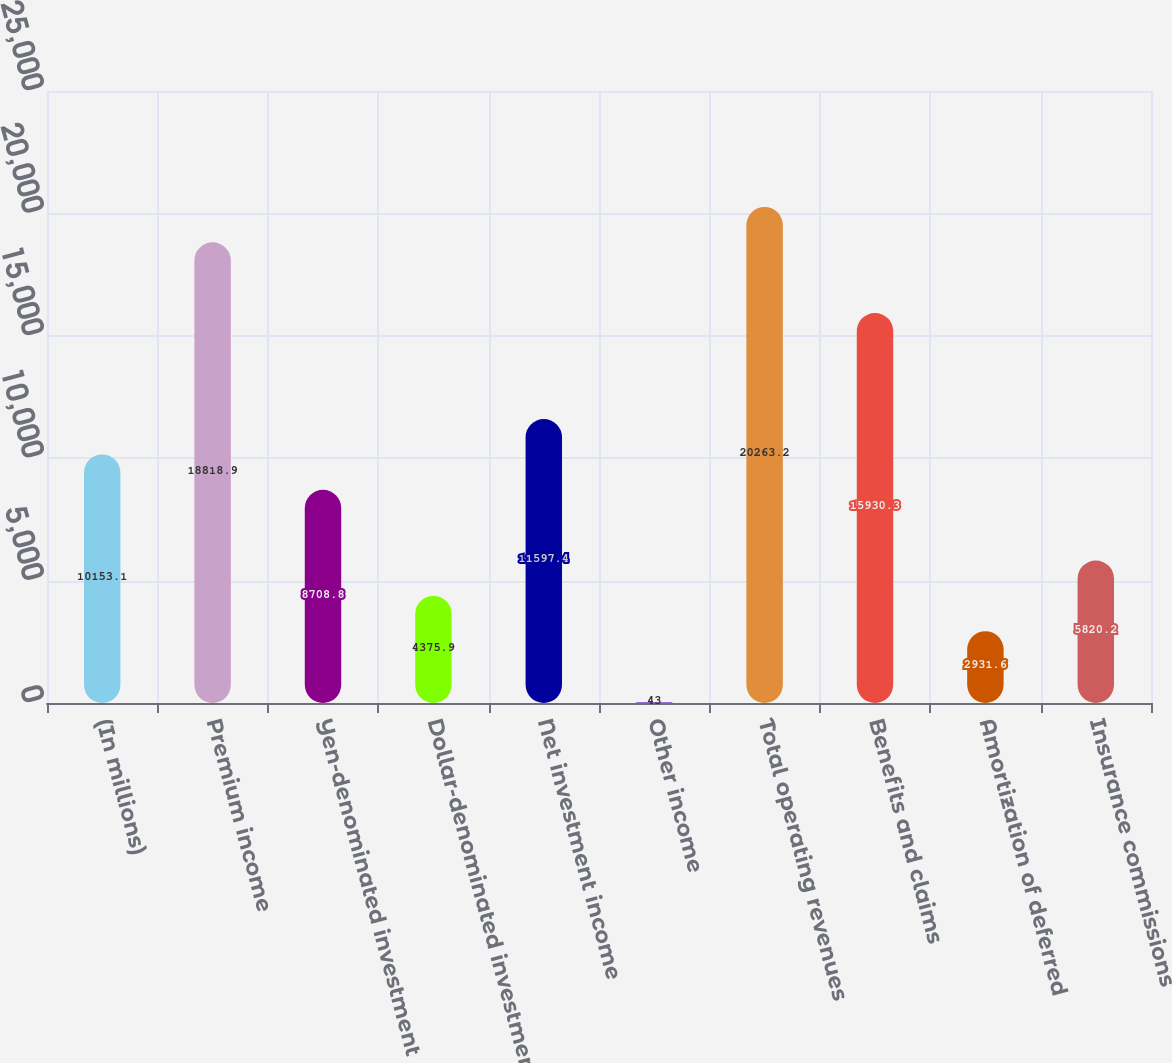<chart> <loc_0><loc_0><loc_500><loc_500><bar_chart><fcel>(In millions)<fcel>Premium income<fcel>Yen-denominated investment<fcel>Dollar-denominated investment<fcel>Net investment income<fcel>Other income<fcel>Total operating revenues<fcel>Benefits and claims<fcel>Amortization of deferred<fcel>Insurance commissions<nl><fcel>10153.1<fcel>18818.9<fcel>8708.8<fcel>4375.9<fcel>11597.4<fcel>43<fcel>20263.2<fcel>15930.3<fcel>2931.6<fcel>5820.2<nl></chart> 